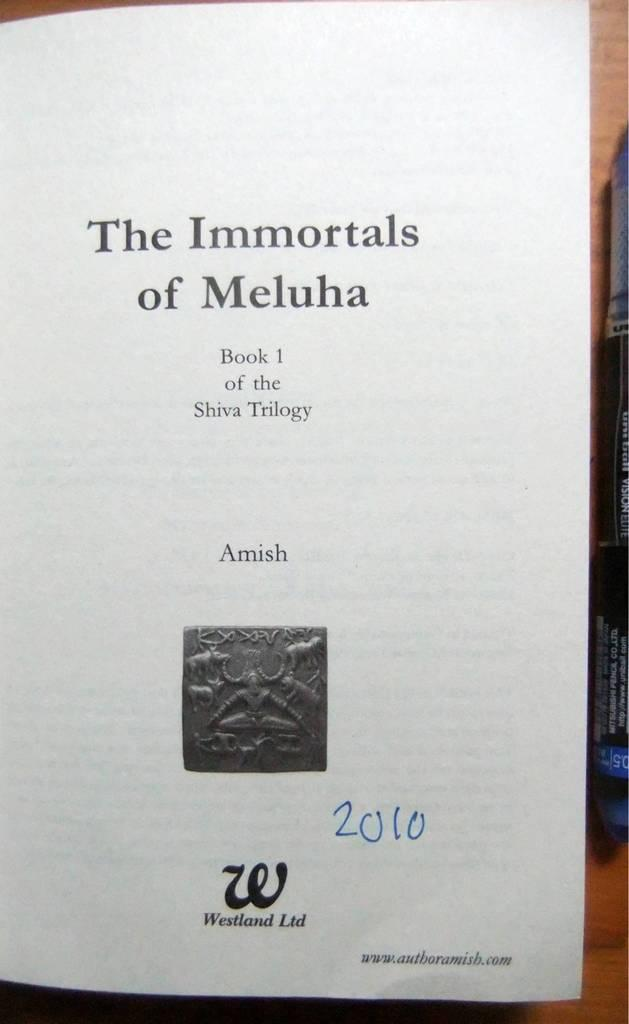<image>
Present a compact description of the photo's key features. An open book that is titled The Immortals of Meluha. 